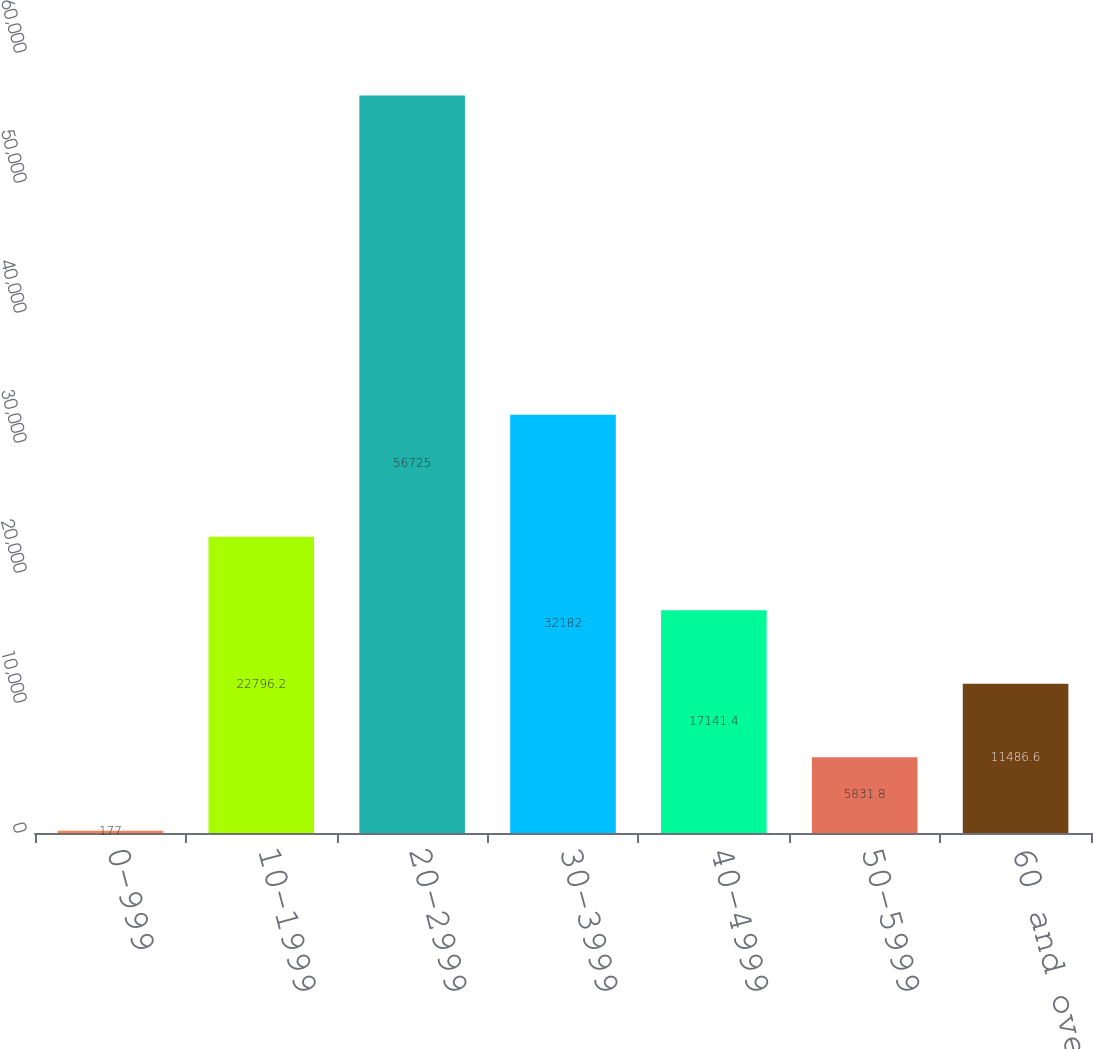Convert chart to OTSL. <chart><loc_0><loc_0><loc_500><loc_500><bar_chart><fcel>0-999<fcel>10-1999<fcel>20-2999<fcel>30-3999<fcel>40-4999<fcel>50-5999<fcel>60 and over<nl><fcel>177<fcel>22796.2<fcel>56725<fcel>32182<fcel>17141.4<fcel>5831.8<fcel>11486.6<nl></chart> 